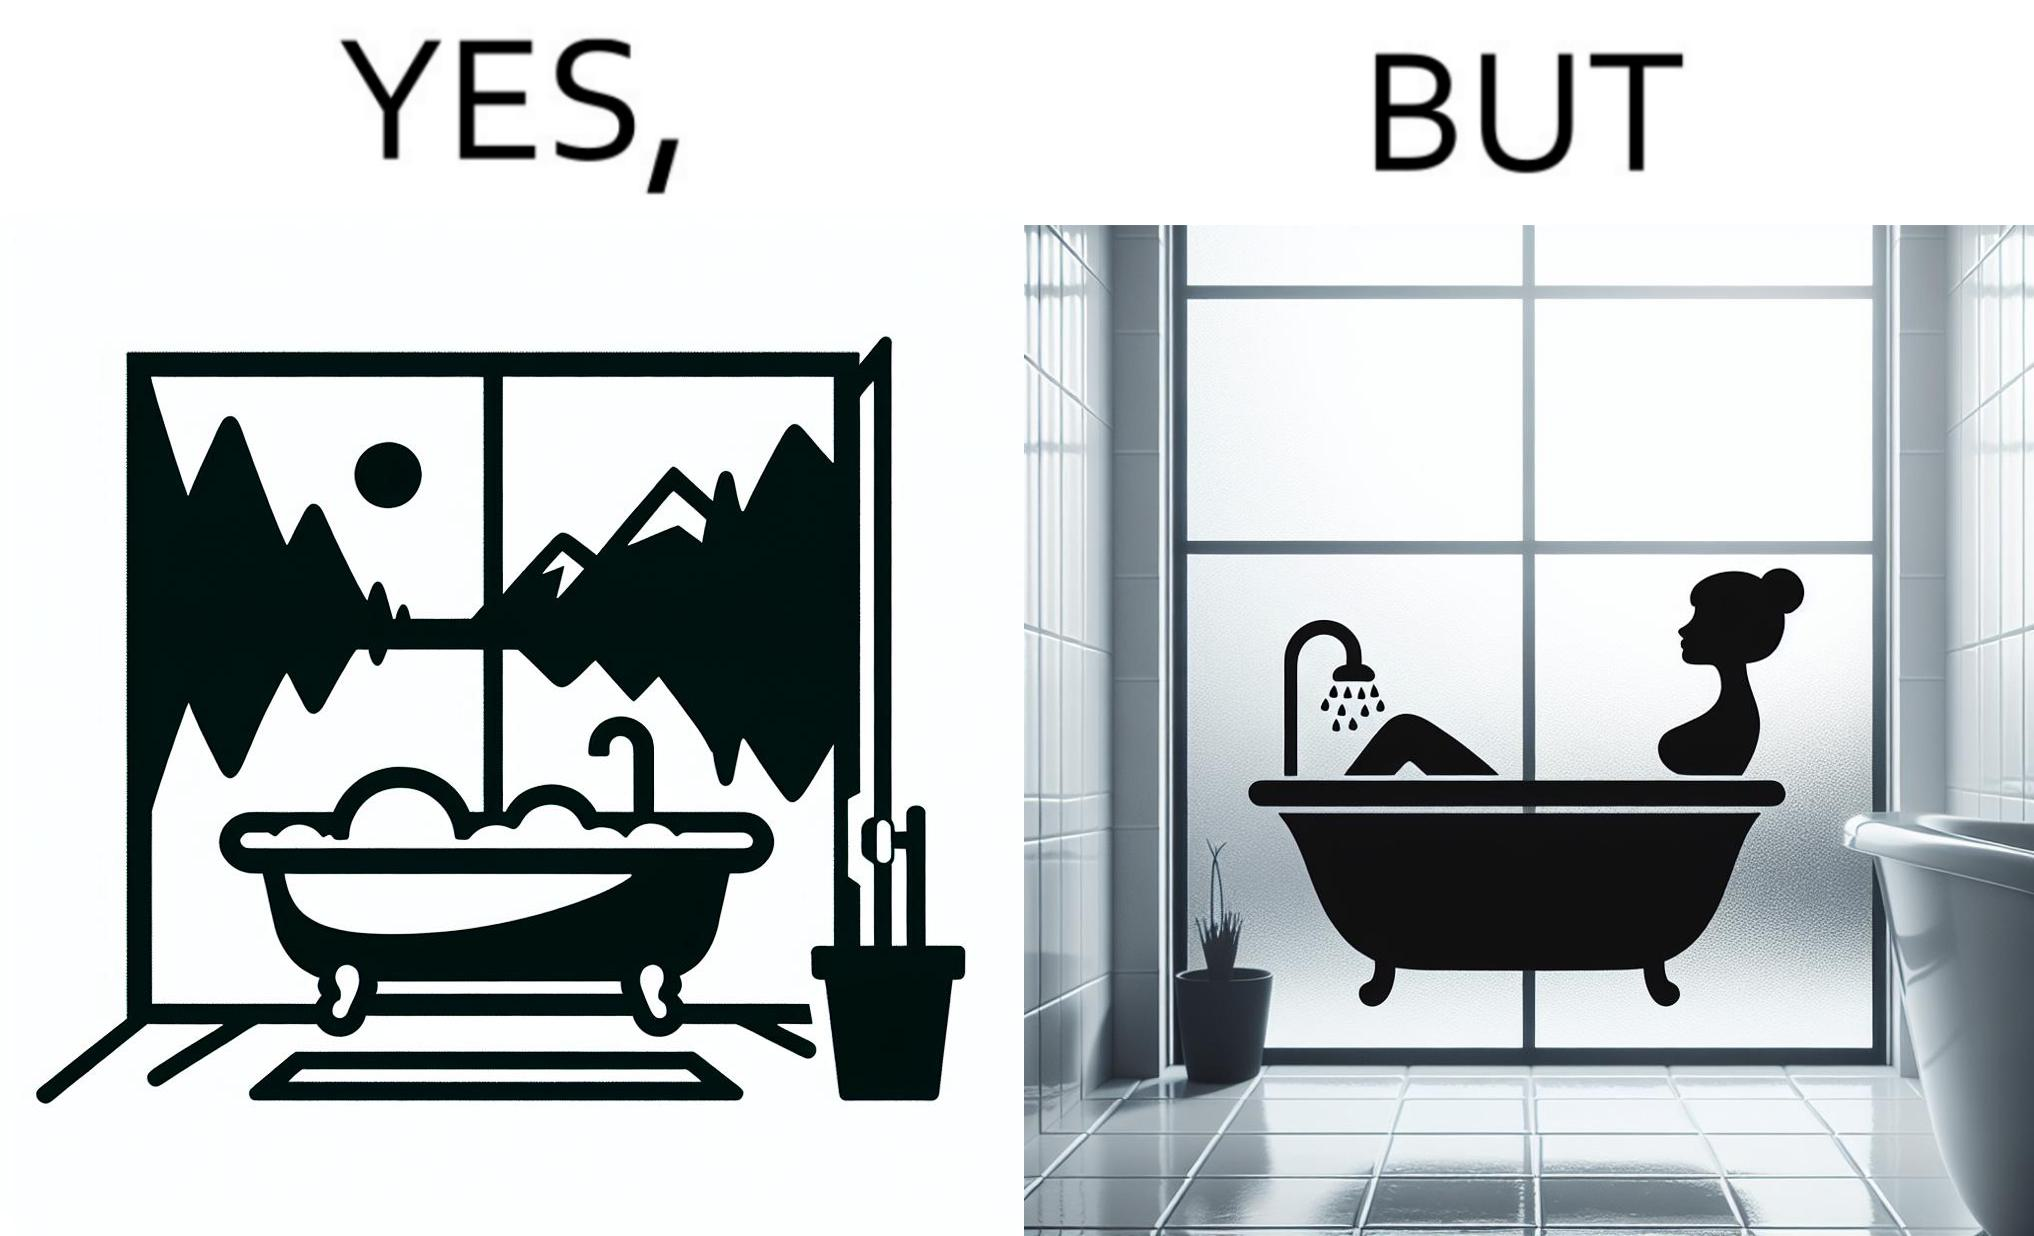Does this image contain satire or humor? Yes, this image is satirical. 